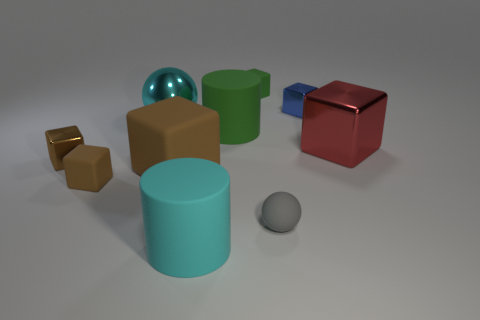Subtract all small blocks. How many blocks are left? 2 Subtract all brown spheres. How many brown blocks are left? 3 Subtract all gray spheres. How many spheres are left? 1 Subtract all spheres. How many objects are left? 8 Subtract 1 spheres. How many spheres are left? 1 Subtract all gray cubes. Subtract all yellow cylinders. How many cubes are left? 6 Subtract all red things. Subtract all blue objects. How many objects are left? 8 Add 2 cyan matte things. How many cyan matte things are left? 3 Add 5 large blocks. How many large blocks exist? 7 Subtract 1 cyan cylinders. How many objects are left? 9 